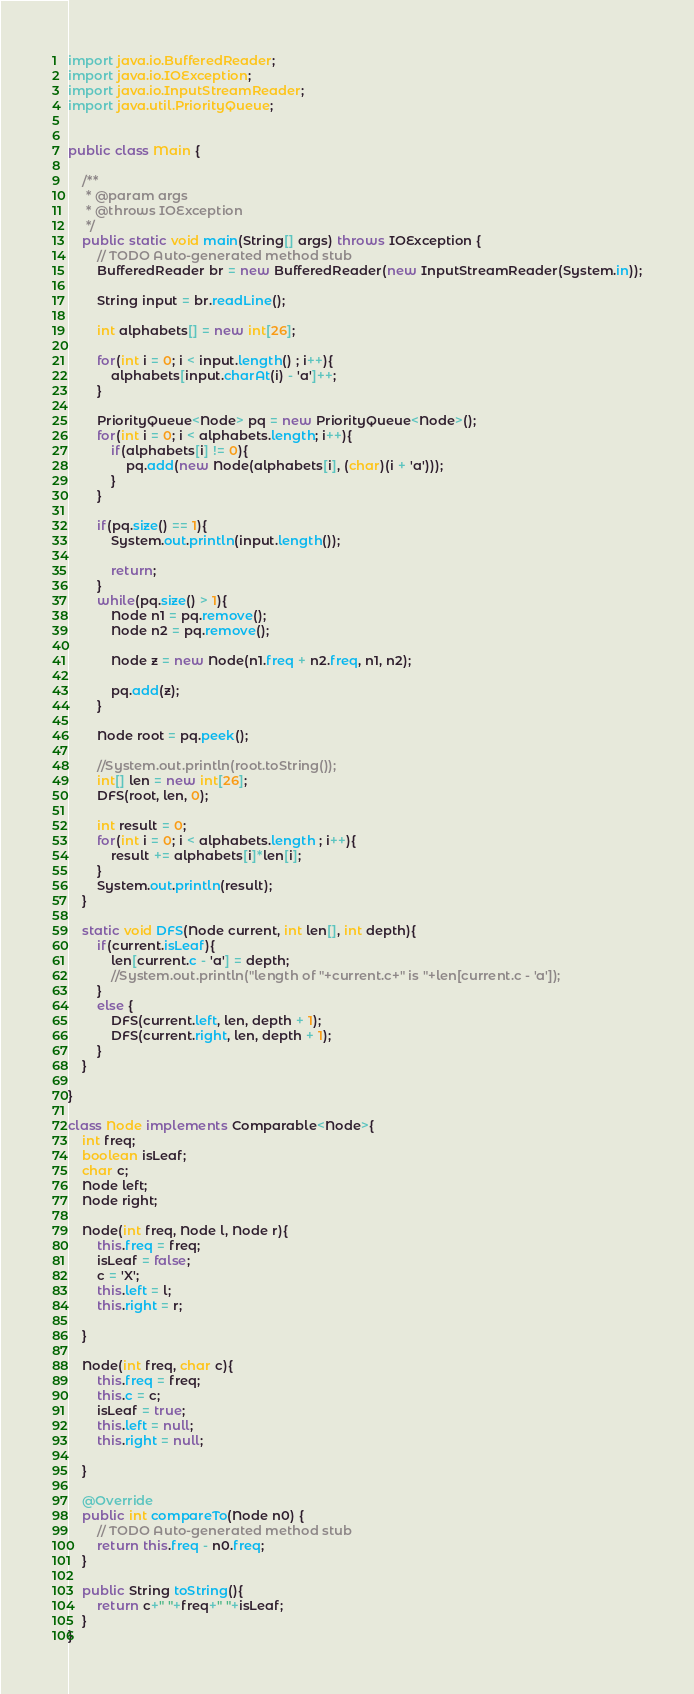Convert code to text. <code><loc_0><loc_0><loc_500><loc_500><_Java_>import java.io.BufferedReader;
import java.io.IOException;
import java.io.InputStreamReader;
import java.util.PriorityQueue;


public class Main {

	/**
	 * @param args
	 * @throws IOException 
	 */
	public static void main(String[] args) throws IOException {
		// TODO Auto-generated method stub
		BufferedReader br = new BufferedReader(new InputStreamReader(System.in));
		
		String input = br.readLine();
		
		int alphabets[] = new int[26];
		
		for(int i = 0; i < input.length() ; i++){
			alphabets[input.charAt(i) - 'a']++;
		}
		
		PriorityQueue<Node> pq = new PriorityQueue<Node>();
		for(int i = 0; i < alphabets.length; i++){
			if(alphabets[i] != 0){
				pq.add(new Node(alphabets[i], (char)(i + 'a')));
			}
		}
		
		if(pq.size() == 1){
			System.out.println(input.length());
			
			return;
		}
		while(pq.size() > 1){
			Node n1 = pq.remove();
			Node n2 = pq.remove();
			
			Node z = new Node(n1.freq + n2.freq, n1, n2);
			
			pq.add(z);
		}
		
		Node root = pq.peek();
		
		//System.out.println(root.toString());
		int[] len = new int[26];
		DFS(root, len, 0);
		
		int result = 0;
		for(int i = 0; i < alphabets.length ; i++){
			result += alphabets[i]*len[i];
		}
		System.out.println(result);
	}
	
	static void DFS(Node current, int len[], int depth){
		if(current.isLeaf){
			len[current.c - 'a'] = depth;
			//System.out.println("length of "+current.c+" is "+len[current.c - 'a']);
		}
		else {
			DFS(current.left, len, depth + 1);
			DFS(current.right, len, depth + 1);
		}
	}

}

class Node implements Comparable<Node>{
	int freq;
	boolean isLeaf;
	char c;
	Node left;
	Node right;
	
	Node(int freq, Node l, Node r){
		this.freq = freq;
		isLeaf = false;
		c = 'X';
		this.left = l;
		this.right = r;
		
	}
	
	Node(int freq, char c){
		this.freq = freq;
		this.c = c;
		isLeaf = true;
		this.left = null;
		this.right = null;
				
	}

	@Override
	public int compareTo(Node n0) {
		// TODO Auto-generated method stub
		return this.freq - n0.freq;
	}
	
	public String toString(){
		return c+" "+freq+" "+isLeaf;
	}
}

</code> 